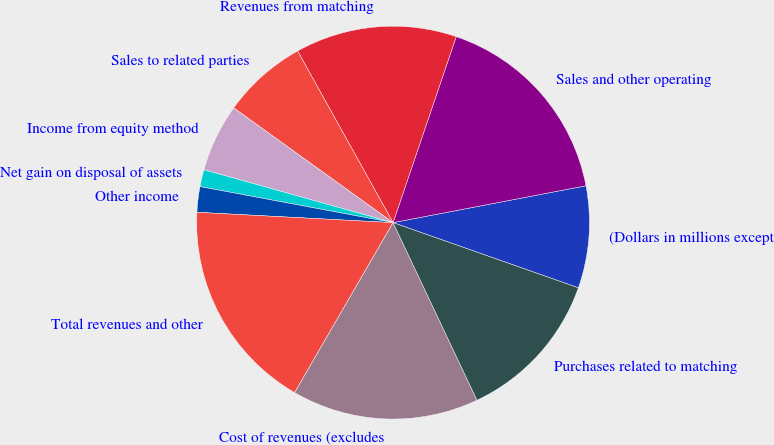Convert chart. <chart><loc_0><loc_0><loc_500><loc_500><pie_chart><fcel>(Dollars in millions except<fcel>Sales and other operating<fcel>Revenues from matching<fcel>Sales to related parties<fcel>Income from equity method<fcel>Net gain on disposal of assets<fcel>Other income<fcel>Total revenues and other<fcel>Cost of revenues (excludes<fcel>Purchases related to matching<nl><fcel>8.39%<fcel>16.78%<fcel>13.29%<fcel>6.99%<fcel>5.59%<fcel>1.4%<fcel>2.1%<fcel>17.48%<fcel>15.38%<fcel>12.59%<nl></chart> 